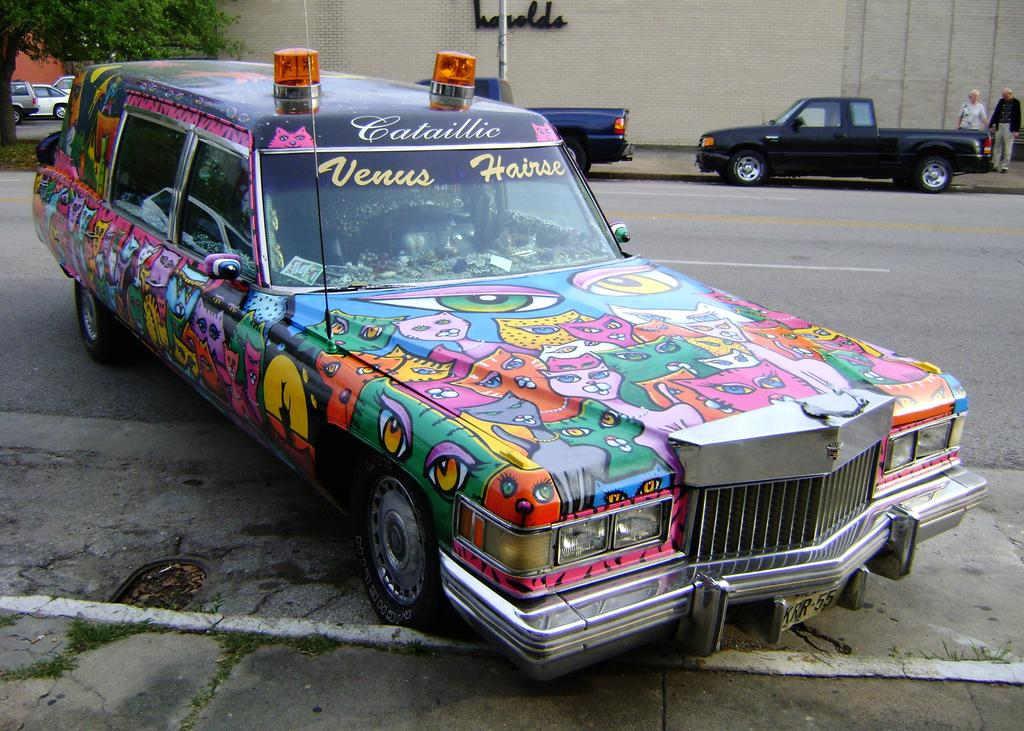What type of car is featured in the image? The car in the image has cartoon pictures on it. What can be seen on the left side of the image? There is a tree on the left side of the image. What is located at the top of the image? There is a building at the top of the image. What are the two persons on the right side of the image doing? The two persons are walking on the right side of the image. What type of cap is the car wearing in the image? The car in the image is not wearing a cap; it is a vehicle with cartoon pictures on it. What kind of lunch is being served in the image? There is no mention of lunch in the image; it features a car, a tree, a building, and two persons walking. 